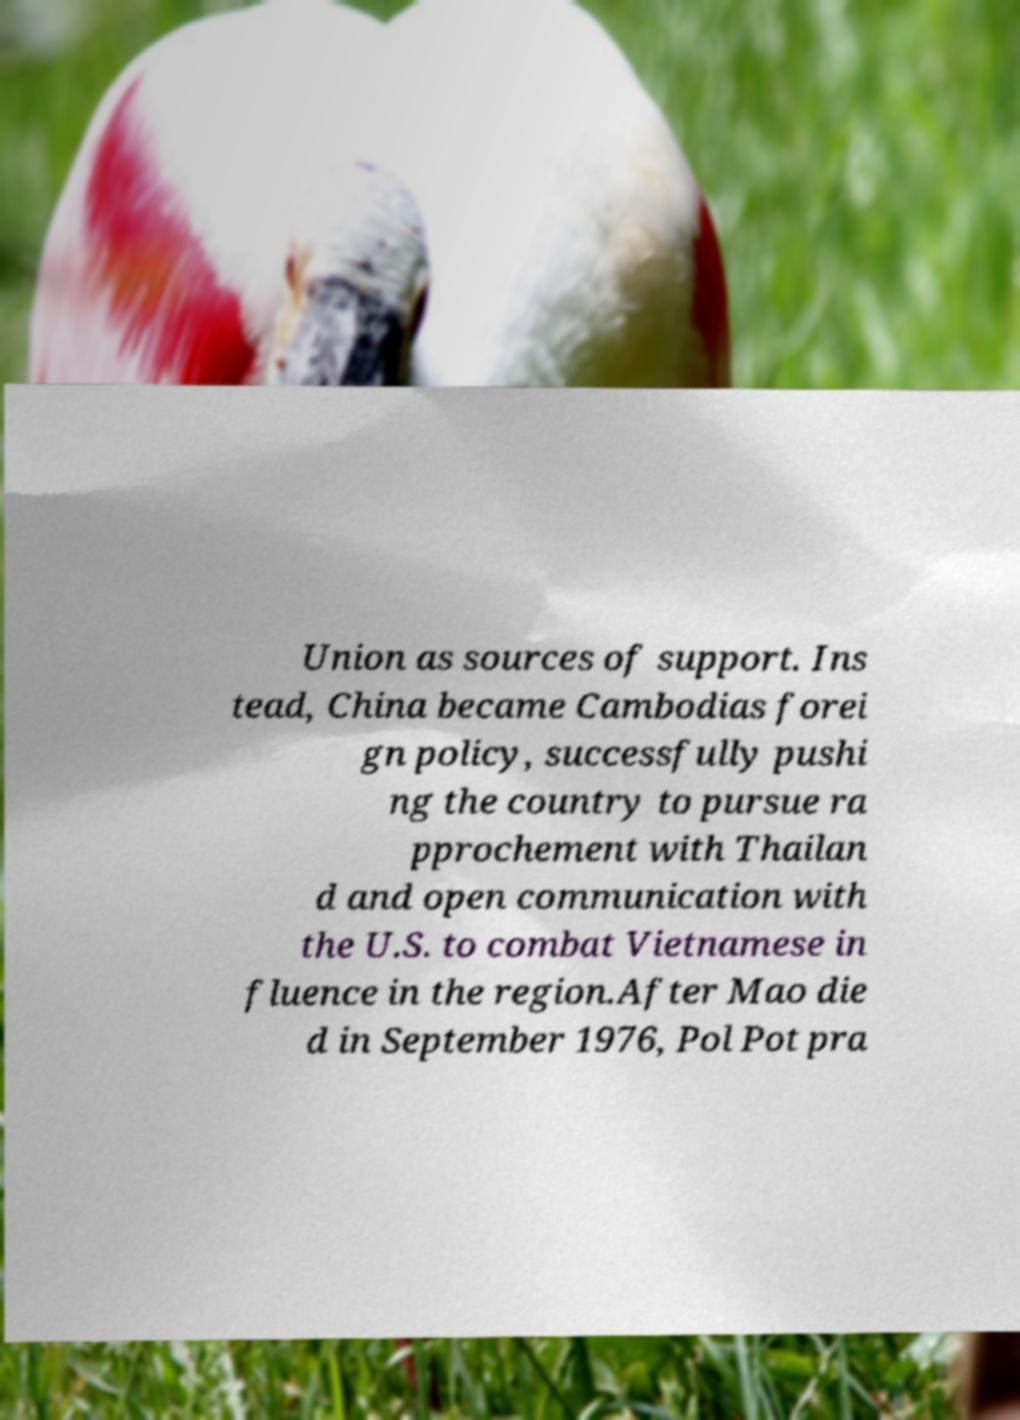For documentation purposes, I need the text within this image transcribed. Could you provide that? Union as sources of support. Ins tead, China became Cambodias forei gn policy, successfully pushi ng the country to pursue ra pprochement with Thailan d and open communication with the U.S. to combat Vietnamese in fluence in the region.After Mao die d in September 1976, Pol Pot pra 